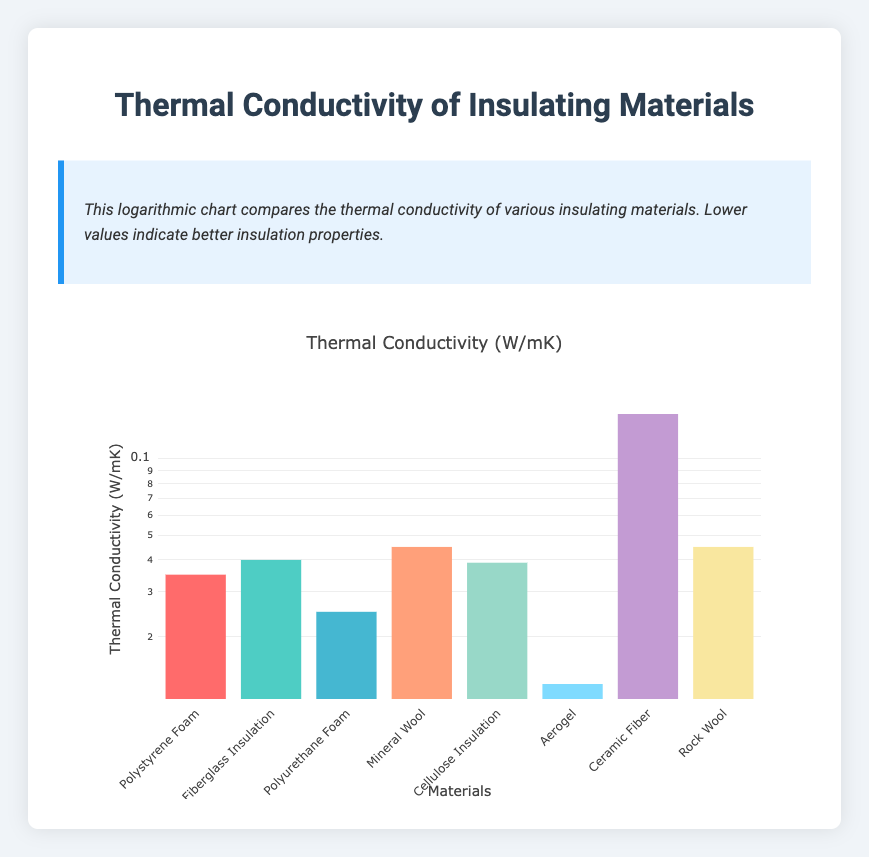What is the thermal conductivity of Aerogel? The table lists Aerogel with a thermal conductivity of 0.013 W/mK, which is directly visible in the data.
Answer: 0.013 W/mK Which material has the highest thermal conductivity? The table shows that Ceramic Fiber has a thermal conductivity of 0.150 W/mK, which is the highest among the listed materials.
Answer: Ceramic Fiber What is the average thermal conductivity of the three materials with the lowest values? The lowest three thermal conductivities are Aerogel (0.013), Polyurethane Foam (0.025), and Polystyrene Foam (0.035). To find the average, we sum these values: 0.013 + 0.025 + 0.035 = 0.073, and then divide by 3: 0.073 / 3 = 0.02433.
Answer: 0.02433 W/mK Is the thermal conductivity of Fiberglass Insulation higher than that of Cellulose Insulation? The table shows Fiberglass Insulation at 0.040 W/mK and Cellulose Insulation at 0.039 W/mK. Since 0.040 is greater than 0.039, the answer is yes.
Answer: Yes If we combine the thermal conductivities of Rock Wool and Mineral Wool, what is the total? Rock Wool has a thermal conductivity of 0.045 W/mK and Mineral Wool also has 0.045 W/mK. Adding these together gives 0.045 + 0.045 = 0.090 W/mK.
Answer: 0.090 W/mK 